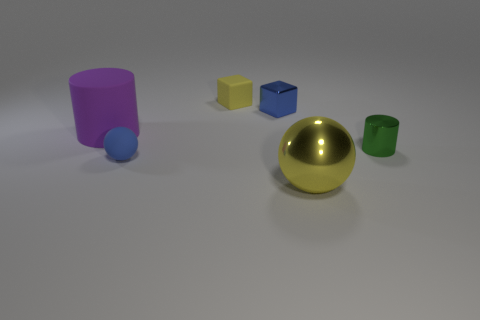Add 1 yellow metal balls. How many objects exist? 7 Add 3 large yellow balls. How many large yellow balls are left? 4 Add 1 large red rubber things. How many large red rubber things exist? 1 Subtract 0 red cylinders. How many objects are left? 6 Subtract all matte blocks. Subtract all tiny matte balls. How many objects are left? 4 